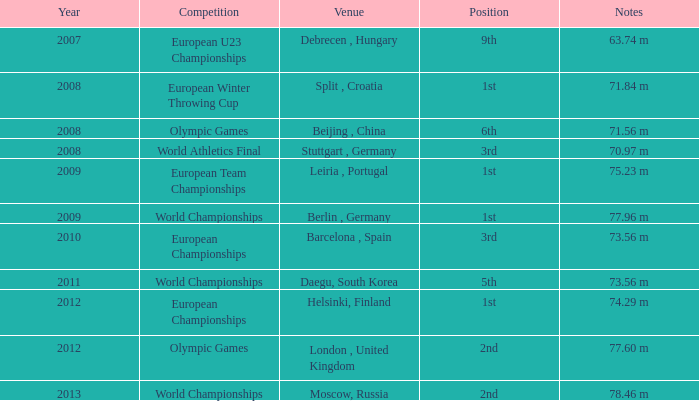Which year corresponds to the 9th rank? 2007.0. 